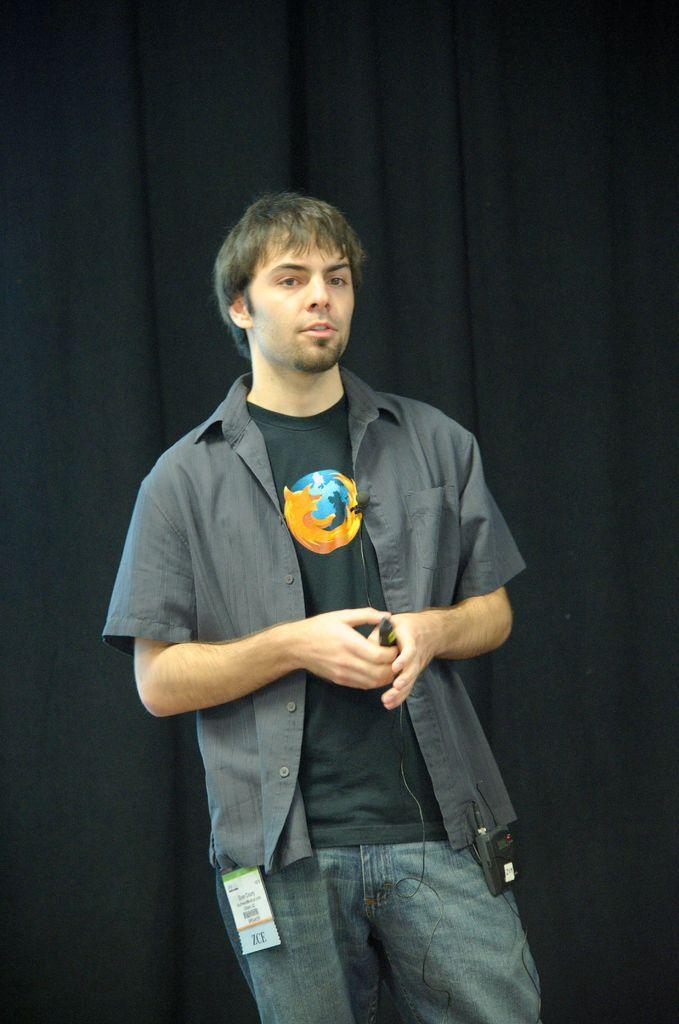What is the main subject of the image? There is a man standing in the image. What is the man wearing? The man is wearing clothes. What is the man holding in his hand? The man is holding an object in his hand. What else can be seen in the image besides the man? There are cable wires, a microphone, and curtains visible in the image. What type of butter is being used by the cow in the image? There is no cow or butter present in the image. How many cans are visible in the image? There are no cans visible in the image. 